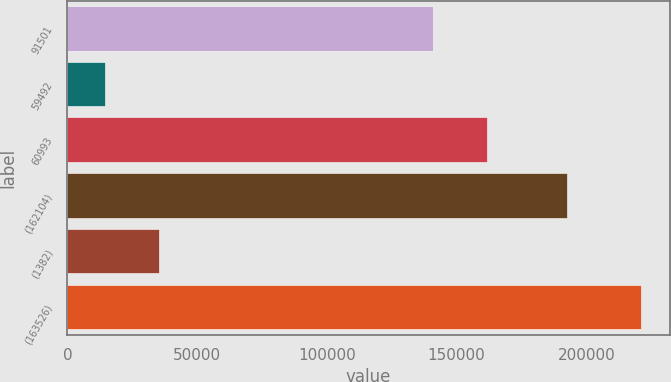Convert chart to OTSL. <chart><loc_0><loc_0><loc_500><loc_500><bar_chart><fcel>91501<fcel>59492<fcel>60993<fcel>(162104)<fcel>(1382)<fcel>(163526)<nl><fcel>140980<fcel>14590<fcel>161626<fcel>192530<fcel>35235.8<fcel>221048<nl></chart> 